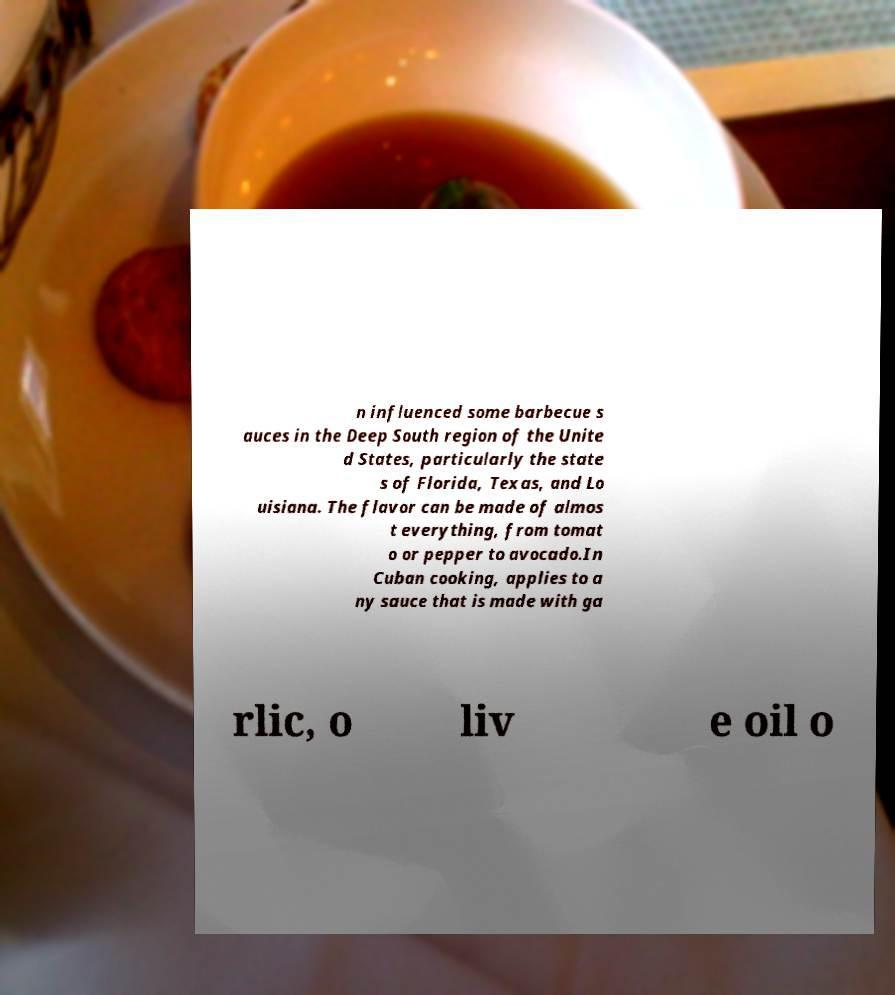I need the written content from this picture converted into text. Can you do that? n influenced some barbecue s auces in the Deep South region of the Unite d States, particularly the state s of Florida, Texas, and Lo uisiana. The flavor can be made of almos t everything, from tomat o or pepper to avocado.In Cuban cooking, applies to a ny sauce that is made with ga rlic, o liv e oil o 